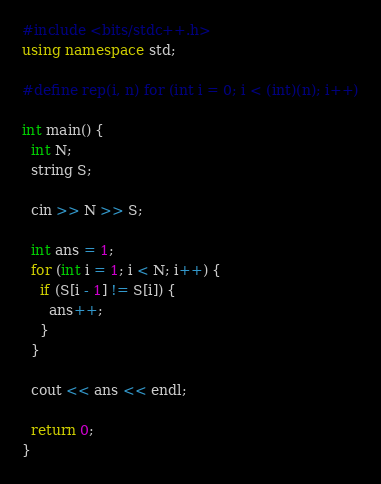Convert code to text. <code><loc_0><loc_0><loc_500><loc_500><_C++_>#include <bits/stdc++.h>
using namespace std;

#define rep(i, n) for (int i = 0; i < (int)(n); i++)

int main() {
  int N;
  string S;

  cin >> N >> S;

  int ans = 1;
  for (int i = 1; i < N; i++) {
    if (S[i - 1] != S[i]) {
      ans++;
    }
  }

  cout << ans << endl;

  return 0;
}
</code> 